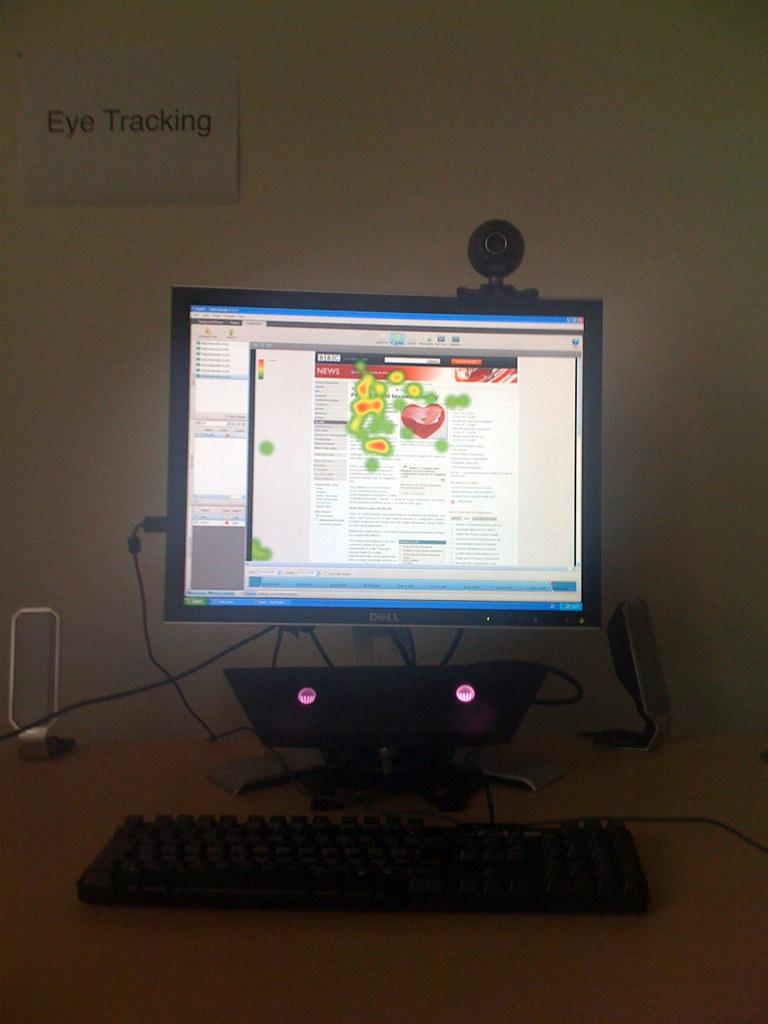<image>
Summarize the visual content of the image. A Dell monitor with a camera mounted on top of it for Eye Tracking. 